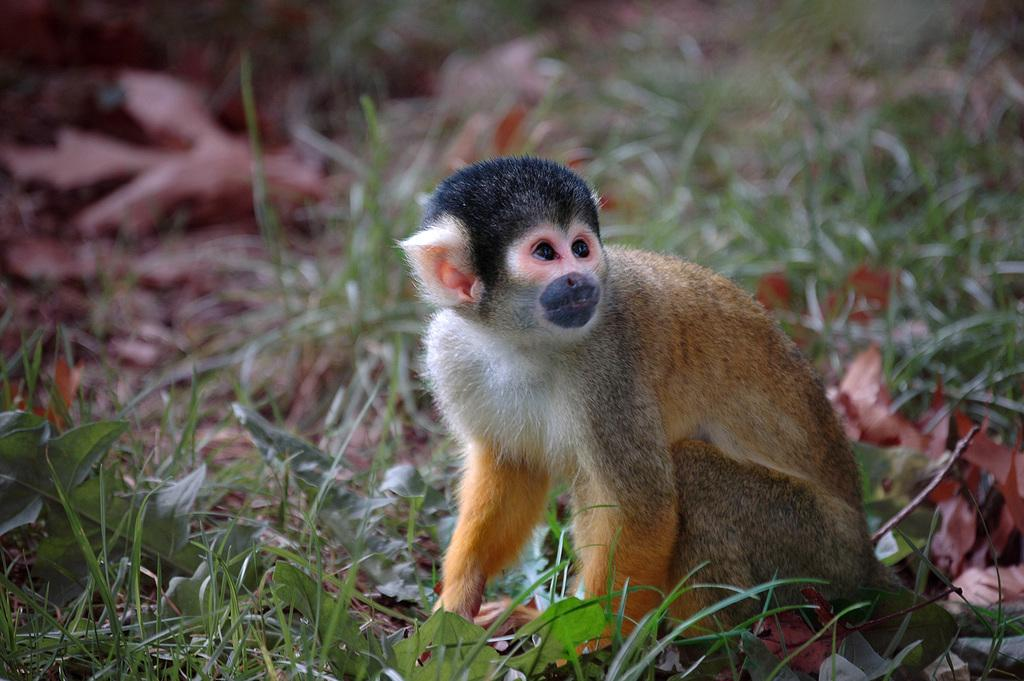What type of vegetation is in the front of the image? There are small plants in the front of the image. What is covering the ground in the image? There is grass on the ground in the image. What animal is located in the center of the image? There is a monkey in the center of the image. What type of vegetation can be seen in the background of the image? There is grass visible in the background of the image. How does the taste of the grass change in the image? The image does not provide information about the taste of the grass, so it cannot be determined from the image. What is the temperature in the image? The image does not provide information about the temperature, so it cannot be determined from the image. 